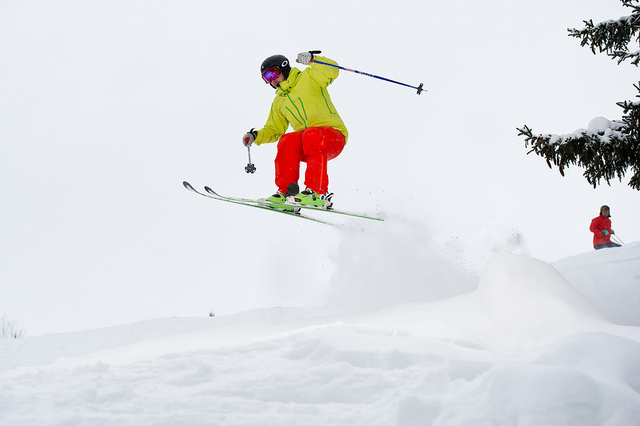<image>What pattern is on the shirt? I don't know. The pattern on the shirt can be solid or stripes. What pattern is on the shirt? I don't know the pattern on the shirt. It can be seen as solid, stripe, or lines. 